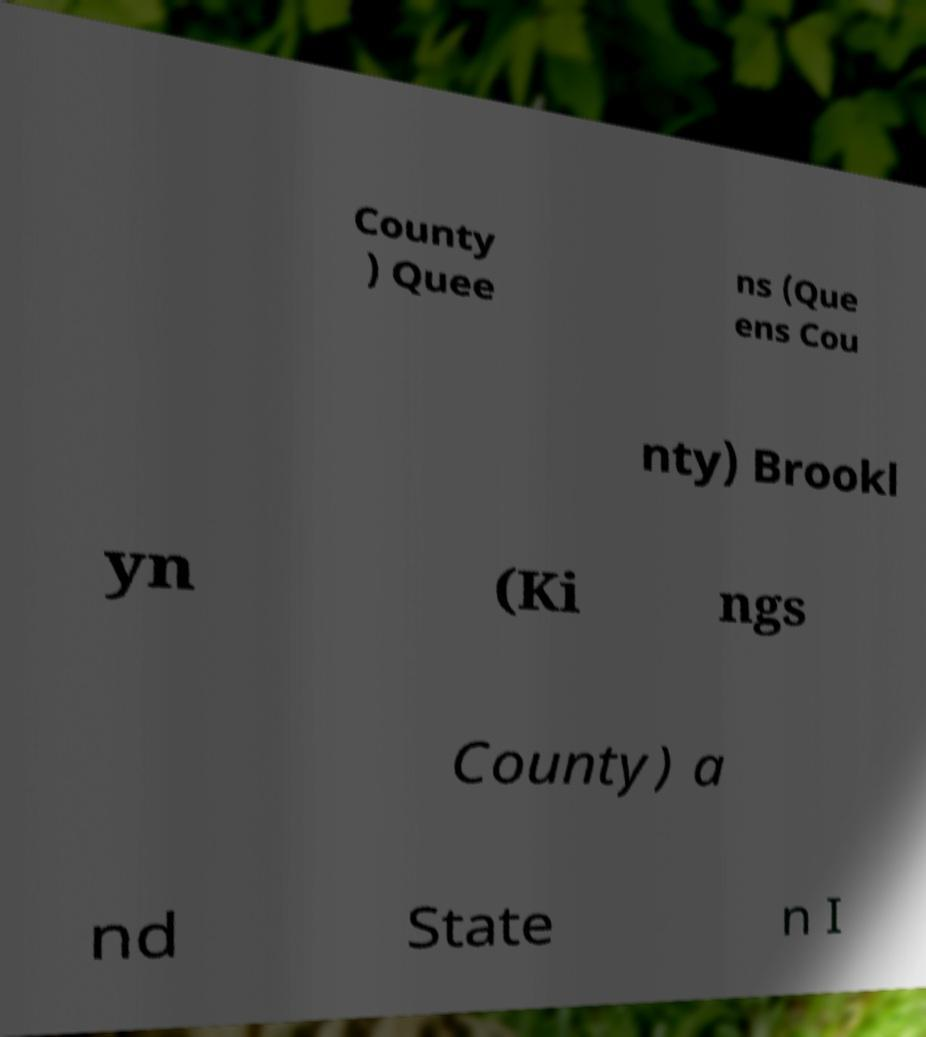Could you assist in decoding the text presented in this image and type it out clearly? County ) Quee ns (Que ens Cou nty) Brookl yn (Ki ngs County) a nd State n I 